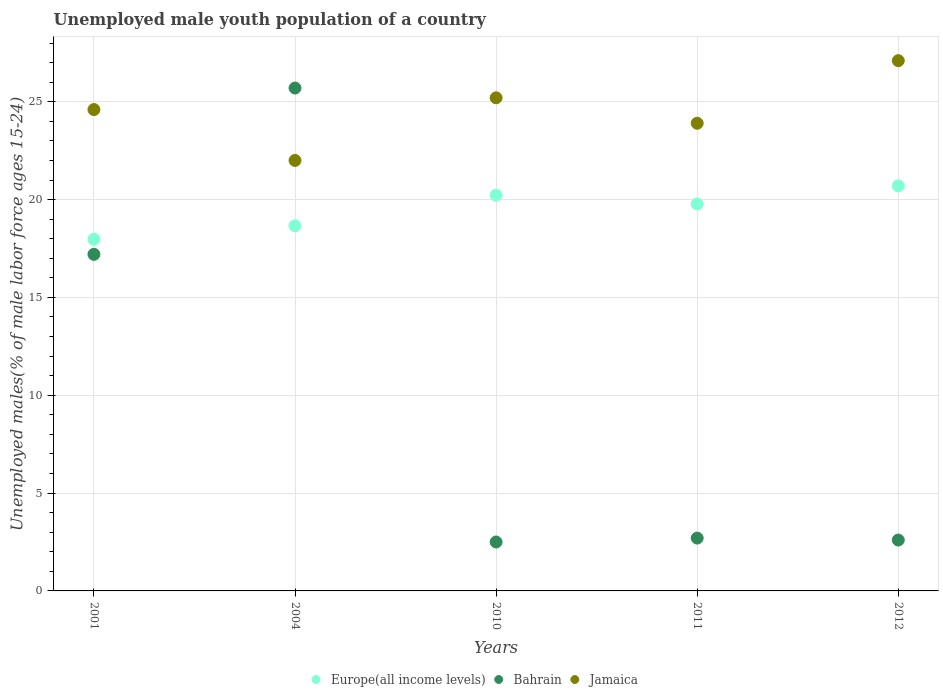How many different coloured dotlines are there?
Your response must be concise. 3. Is the number of dotlines equal to the number of legend labels?
Provide a succinct answer. Yes. What is the percentage of unemployed male youth population in Jamaica in 2004?
Your response must be concise. 22. Across all years, what is the maximum percentage of unemployed male youth population in Jamaica?
Provide a short and direct response. 27.1. In which year was the percentage of unemployed male youth population in Jamaica minimum?
Give a very brief answer. 2004. What is the total percentage of unemployed male youth population in Bahrain in the graph?
Give a very brief answer. 50.7. What is the difference between the percentage of unemployed male youth population in Europe(all income levels) in 2001 and that in 2011?
Your answer should be compact. -1.8. What is the difference between the percentage of unemployed male youth population in Europe(all income levels) in 2001 and the percentage of unemployed male youth population in Bahrain in 2010?
Give a very brief answer. 15.47. What is the average percentage of unemployed male youth population in Bahrain per year?
Your response must be concise. 10.14. In the year 2011, what is the difference between the percentage of unemployed male youth population in Jamaica and percentage of unemployed male youth population in Bahrain?
Your response must be concise. 21.2. In how many years, is the percentage of unemployed male youth population in Jamaica greater than 15 %?
Your answer should be very brief. 5. What is the ratio of the percentage of unemployed male youth population in Europe(all income levels) in 2001 to that in 2004?
Ensure brevity in your answer.  0.96. What is the difference between the highest and the second highest percentage of unemployed male youth population in Europe(all income levels)?
Your answer should be very brief. 0.48. What is the difference between the highest and the lowest percentage of unemployed male youth population in Bahrain?
Offer a very short reply. 23.2. Is the sum of the percentage of unemployed male youth population in Europe(all income levels) in 2010 and 2012 greater than the maximum percentage of unemployed male youth population in Jamaica across all years?
Offer a terse response. Yes. Is it the case that in every year, the sum of the percentage of unemployed male youth population in Jamaica and percentage of unemployed male youth population in Europe(all income levels)  is greater than the percentage of unemployed male youth population in Bahrain?
Your answer should be very brief. Yes. Does the percentage of unemployed male youth population in Europe(all income levels) monotonically increase over the years?
Make the answer very short. No. Is the percentage of unemployed male youth population in Jamaica strictly greater than the percentage of unemployed male youth population in Bahrain over the years?
Provide a short and direct response. No. How many dotlines are there?
Your answer should be compact. 3. What is the difference between two consecutive major ticks on the Y-axis?
Give a very brief answer. 5. Are the values on the major ticks of Y-axis written in scientific E-notation?
Provide a short and direct response. No. Does the graph contain any zero values?
Your response must be concise. No. How many legend labels are there?
Offer a very short reply. 3. What is the title of the graph?
Offer a very short reply. Unemployed male youth population of a country. What is the label or title of the X-axis?
Provide a succinct answer. Years. What is the label or title of the Y-axis?
Ensure brevity in your answer.  Unemployed males(% of male labor force ages 15-24). What is the Unemployed males(% of male labor force ages 15-24) of Europe(all income levels) in 2001?
Provide a succinct answer. 17.97. What is the Unemployed males(% of male labor force ages 15-24) in Bahrain in 2001?
Make the answer very short. 17.2. What is the Unemployed males(% of male labor force ages 15-24) of Jamaica in 2001?
Your answer should be very brief. 24.6. What is the Unemployed males(% of male labor force ages 15-24) in Europe(all income levels) in 2004?
Your response must be concise. 18.66. What is the Unemployed males(% of male labor force ages 15-24) of Bahrain in 2004?
Provide a succinct answer. 25.7. What is the Unemployed males(% of male labor force ages 15-24) of Europe(all income levels) in 2010?
Provide a short and direct response. 20.22. What is the Unemployed males(% of male labor force ages 15-24) of Jamaica in 2010?
Your answer should be compact. 25.2. What is the Unemployed males(% of male labor force ages 15-24) in Europe(all income levels) in 2011?
Keep it short and to the point. 19.77. What is the Unemployed males(% of male labor force ages 15-24) of Bahrain in 2011?
Offer a very short reply. 2.7. What is the Unemployed males(% of male labor force ages 15-24) in Jamaica in 2011?
Make the answer very short. 23.9. What is the Unemployed males(% of male labor force ages 15-24) in Europe(all income levels) in 2012?
Provide a short and direct response. 20.7. What is the Unemployed males(% of male labor force ages 15-24) of Bahrain in 2012?
Provide a short and direct response. 2.6. What is the Unemployed males(% of male labor force ages 15-24) in Jamaica in 2012?
Offer a very short reply. 27.1. Across all years, what is the maximum Unemployed males(% of male labor force ages 15-24) of Europe(all income levels)?
Keep it short and to the point. 20.7. Across all years, what is the maximum Unemployed males(% of male labor force ages 15-24) of Bahrain?
Your answer should be very brief. 25.7. Across all years, what is the maximum Unemployed males(% of male labor force ages 15-24) in Jamaica?
Make the answer very short. 27.1. Across all years, what is the minimum Unemployed males(% of male labor force ages 15-24) of Europe(all income levels)?
Offer a very short reply. 17.97. What is the total Unemployed males(% of male labor force ages 15-24) in Europe(all income levels) in the graph?
Provide a short and direct response. 97.33. What is the total Unemployed males(% of male labor force ages 15-24) in Bahrain in the graph?
Your response must be concise. 50.7. What is the total Unemployed males(% of male labor force ages 15-24) in Jamaica in the graph?
Provide a short and direct response. 122.8. What is the difference between the Unemployed males(% of male labor force ages 15-24) in Europe(all income levels) in 2001 and that in 2004?
Your response must be concise. -0.69. What is the difference between the Unemployed males(% of male labor force ages 15-24) of Jamaica in 2001 and that in 2004?
Give a very brief answer. 2.6. What is the difference between the Unemployed males(% of male labor force ages 15-24) in Europe(all income levels) in 2001 and that in 2010?
Give a very brief answer. -2.25. What is the difference between the Unemployed males(% of male labor force ages 15-24) in Jamaica in 2001 and that in 2010?
Keep it short and to the point. -0.6. What is the difference between the Unemployed males(% of male labor force ages 15-24) of Europe(all income levels) in 2001 and that in 2011?
Make the answer very short. -1.8. What is the difference between the Unemployed males(% of male labor force ages 15-24) of Bahrain in 2001 and that in 2011?
Your answer should be compact. 14.5. What is the difference between the Unemployed males(% of male labor force ages 15-24) of Jamaica in 2001 and that in 2011?
Offer a terse response. 0.7. What is the difference between the Unemployed males(% of male labor force ages 15-24) in Europe(all income levels) in 2001 and that in 2012?
Offer a very short reply. -2.73. What is the difference between the Unemployed males(% of male labor force ages 15-24) of Jamaica in 2001 and that in 2012?
Ensure brevity in your answer.  -2.5. What is the difference between the Unemployed males(% of male labor force ages 15-24) in Europe(all income levels) in 2004 and that in 2010?
Make the answer very short. -1.56. What is the difference between the Unemployed males(% of male labor force ages 15-24) of Bahrain in 2004 and that in 2010?
Keep it short and to the point. 23.2. What is the difference between the Unemployed males(% of male labor force ages 15-24) of Europe(all income levels) in 2004 and that in 2011?
Your answer should be very brief. -1.11. What is the difference between the Unemployed males(% of male labor force ages 15-24) of Europe(all income levels) in 2004 and that in 2012?
Make the answer very short. -2.04. What is the difference between the Unemployed males(% of male labor force ages 15-24) of Bahrain in 2004 and that in 2012?
Give a very brief answer. 23.1. What is the difference between the Unemployed males(% of male labor force ages 15-24) in Jamaica in 2004 and that in 2012?
Your response must be concise. -5.1. What is the difference between the Unemployed males(% of male labor force ages 15-24) in Europe(all income levels) in 2010 and that in 2011?
Make the answer very short. 0.45. What is the difference between the Unemployed males(% of male labor force ages 15-24) of Europe(all income levels) in 2010 and that in 2012?
Ensure brevity in your answer.  -0.48. What is the difference between the Unemployed males(% of male labor force ages 15-24) of Jamaica in 2010 and that in 2012?
Offer a terse response. -1.9. What is the difference between the Unemployed males(% of male labor force ages 15-24) in Europe(all income levels) in 2011 and that in 2012?
Give a very brief answer. -0.93. What is the difference between the Unemployed males(% of male labor force ages 15-24) of Europe(all income levels) in 2001 and the Unemployed males(% of male labor force ages 15-24) of Bahrain in 2004?
Offer a terse response. -7.73. What is the difference between the Unemployed males(% of male labor force ages 15-24) in Europe(all income levels) in 2001 and the Unemployed males(% of male labor force ages 15-24) in Jamaica in 2004?
Keep it short and to the point. -4.03. What is the difference between the Unemployed males(% of male labor force ages 15-24) in Bahrain in 2001 and the Unemployed males(% of male labor force ages 15-24) in Jamaica in 2004?
Your response must be concise. -4.8. What is the difference between the Unemployed males(% of male labor force ages 15-24) in Europe(all income levels) in 2001 and the Unemployed males(% of male labor force ages 15-24) in Bahrain in 2010?
Offer a very short reply. 15.47. What is the difference between the Unemployed males(% of male labor force ages 15-24) in Europe(all income levels) in 2001 and the Unemployed males(% of male labor force ages 15-24) in Jamaica in 2010?
Offer a terse response. -7.23. What is the difference between the Unemployed males(% of male labor force ages 15-24) in Bahrain in 2001 and the Unemployed males(% of male labor force ages 15-24) in Jamaica in 2010?
Offer a terse response. -8. What is the difference between the Unemployed males(% of male labor force ages 15-24) in Europe(all income levels) in 2001 and the Unemployed males(% of male labor force ages 15-24) in Bahrain in 2011?
Offer a terse response. 15.27. What is the difference between the Unemployed males(% of male labor force ages 15-24) of Europe(all income levels) in 2001 and the Unemployed males(% of male labor force ages 15-24) of Jamaica in 2011?
Provide a succinct answer. -5.93. What is the difference between the Unemployed males(% of male labor force ages 15-24) of Europe(all income levels) in 2001 and the Unemployed males(% of male labor force ages 15-24) of Bahrain in 2012?
Offer a terse response. 15.37. What is the difference between the Unemployed males(% of male labor force ages 15-24) in Europe(all income levels) in 2001 and the Unemployed males(% of male labor force ages 15-24) in Jamaica in 2012?
Keep it short and to the point. -9.13. What is the difference between the Unemployed males(% of male labor force ages 15-24) of Bahrain in 2001 and the Unemployed males(% of male labor force ages 15-24) of Jamaica in 2012?
Keep it short and to the point. -9.9. What is the difference between the Unemployed males(% of male labor force ages 15-24) of Europe(all income levels) in 2004 and the Unemployed males(% of male labor force ages 15-24) of Bahrain in 2010?
Offer a terse response. 16.16. What is the difference between the Unemployed males(% of male labor force ages 15-24) of Europe(all income levels) in 2004 and the Unemployed males(% of male labor force ages 15-24) of Jamaica in 2010?
Keep it short and to the point. -6.54. What is the difference between the Unemployed males(% of male labor force ages 15-24) in Europe(all income levels) in 2004 and the Unemployed males(% of male labor force ages 15-24) in Bahrain in 2011?
Make the answer very short. 15.96. What is the difference between the Unemployed males(% of male labor force ages 15-24) in Europe(all income levels) in 2004 and the Unemployed males(% of male labor force ages 15-24) in Jamaica in 2011?
Give a very brief answer. -5.24. What is the difference between the Unemployed males(% of male labor force ages 15-24) of Europe(all income levels) in 2004 and the Unemployed males(% of male labor force ages 15-24) of Bahrain in 2012?
Offer a very short reply. 16.06. What is the difference between the Unemployed males(% of male labor force ages 15-24) of Europe(all income levels) in 2004 and the Unemployed males(% of male labor force ages 15-24) of Jamaica in 2012?
Make the answer very short. -8.44. What is the difference between the Unemployed males(% of male labor force ages 15-24) of Europe(all income levels) in 2010 and the Unemployed males(% of male labor force ages 15-24) of Bahrain in 2011?
Give a very brief answer. 17.52. What is the difference between the Unemployed males(% of male labor force ages 15-24) in Europe(all income levels) in 2010 and the Unemployed males(% of male labor force ages 15-24) in Jamaica in 2011?
Your answer should be compact. -3.68. What is the difference between the Unemployed males(% of male labor force ages 15-24) of Bahrain in 2010 and the Unemployed males(% of male labor force ages 15-24) of Jamaica in 2011?
Offer a terse response. -21.4. What is the difference between the Unemployed males(% of male labor force ages 15-24) in Europe(all income levels) in 2010 and the Unemployed males(% of male labor force ages 15-24) in Bahrain in 2012?
Make the answer very short. 17.62. What is the difference between the Unemployed males(% of male labor force ages 15-24) in Europe(all income levels) in 2010 and the Unemployed males(% of male labor force ages 15-24) in Jamaica in 2012?
Your answer should be compact. -6.88. What is the difference between the Unemployed males(% of male labor force ages 15-24) in Bahrain in 2010 and the Unemployed males(% of male labor force ages 15-24) in Jamaica in 2012?
Provide a succinct answer. -24.6. What is the difference between the Unemployed males(% of male labor force ages 15-24) of Europe(all income levels) in 2011 and the Unemployed males(% of male labor force ages 15-24) of Bahrain in 2012?
Keep it short and to the point. 17.17. What is the difference between the Unemployed males(% of male labor force ages 15-24) of Europe(all income levels) in 2011 and the Unemployed males(% of male labor force ages 15-24) of Jamaica in 2012?
Keep it short and to the point. -7.33. What is the difference between the Unemployed males(% of male labor force ages 15-24) in Bahrain in 2011 and the Unemployed males(% of male labor force ages 15-24) in Jamaica in 2012?
Keep it short and to the point. -24.4. What is the average Unemployed males(% of male labor force ages 15-24) of Europe(all income levels) per year?
Ensure brevity in your answer.  19.47. What is the average Unemployed males(% of male labor force ages 15-24) of Bahrain per year?
Provide a succinct answer. 10.14. What is the average Unemployed males(% of male labor force ages 15-24) in Jamaica per year?
Your answer should be compact. 24.56. In the year 2001, what is the difference between the Unemployed males(% of male labor force ages 15-24) in Europe(all income levels) and Unemployed males(% of male labor force ages 15-24) in Bahrain?
Your answer should be compact. 0.77. In the year 2001, what is the difference between the Unemployed males(% of male labor force ages 15-24) of Europe(all income levels) and Unemployed males(% of male labor force ages 15-24) of Jamaica?
Ensure brevity in your answer.  -6.63. In the year 2001, what is the difference between the Unemployed males(% of male labor force ages 15-24) of Bahrain and Unemployed males(% of male labor force ages 15-24) of Jamaica?
Keep it short and to the point. -7.4. In the year 2004, what is the difference between the Unemployed males(% of male labor force ages 15-24) of Europe(all income levels) and Unemployed males(% of male labor force ages 15-24) of Bahrain?
Provide a succinct answer. -7.04. In the year 2004, what is the difference between the Unemployed males(% of male labor force ages 15-24) in Europe(all income levels) and Unemployed males(% of male labor force ages 15-24) in Jamaica?
Ensure brevity in your answer.  -3.34. In the year 2010, what is the difference between the Unemployed males(% of male labor force ages 15-24) in Europe(all income levels) and Unemployed males(% of male labor force ages 15-24) in Bahrain?
Keep it short and to the point. 17.72. In the year 2010, what is the difference between the Unemployed males(% of male labor force ages 15-24) in Europe(all income levels) and Unemployed males(% of male labor force ages 15-24) in Jamaica?
Give a very brief answer. -4.98. In the year 2010, what is the difference between the Unemployed males(% of male labor force ages 15-24) in Bahrain and Unemployed males(% of male labor force ages 15-24) in Jamaica?
Give a very brief answer. -22.7. In the year 2011, what is the difference between the Unemployed males(% of male labor force ages 15-24) of Europe(all income levels) and Unemployed males(% of male labor force ages 15-24) of Bahrain?
Offer a very short reply. 17.07. In the year 2011, what is the difference between the Unemployed males(% of male labor force ages 15-24) in Europe(all income levels) and Unemployed males(% of male labor force ages 15-24) in Jamaica?
Your answer should be very brief. -4.13. In the year 2011, what is the difference between the Unemployed males(% of male labor force ages 15-24) in Bahrain and Unemployed males(% of male labor force ages 15-24) in Jamaica?
Make the answer very short. -21.2. In the year 2012, what is the difference between the Unemployed males(% of male labor force ages 15-24) of Europe(all income levels) and Unemployed males(% of male labor force ages 15-24) of Bahrain?
Offer a very short reply. 18.1. In the year 2012, what is the difference between the Unemployed males(% of male labor force ages 15-24) in Europe(all income levels) and Unemployed males(% of male labor force ages 15-24) in Jamaica?
Offer a very short reply. -6.4. In the year 2012, what is the difference between the Unemployed males(% of male labor force ages 15-24) in Bahrain and Unemployed males(% of male labor force ages 15-24) in Jamaica?
Your answer should be compact. -24.5. What is the ratio of the Unemployed males(% of male labor force ages 15-24) of Bahrain in 2001 to that in 2004?
Offer a very short reply. 0.67. What is the ratio of the Unemployed males(% of male labor force ages 15-24) of Jamaica in 2001 to that in 2004?
Give a very brief answer. 1.12. What is the ratio of the Unemployed males(% of male labor force ages 15-24) of Europe(all income levels) in 2001 to that in 2010?
Make the answer very short. 0.89. What is the ratio of the Unemployed males(% of male labor force ages 15-24) in Bahrain in 2001 to that in 2010?
Provide a succinct answer. 6.88. What is the ratio of the Unemployed males(% of male labor force ages 15-24) of Jamaica in 2001 to that in 2010?
Offer a very short reply. 0.98. What is the ratio of the Unemployed males(% of male labor force ages 15-24) in Europe(all income levels) in 2001 to that in 2011?
Offer a very short reply. 0.91. What is the ratio of the Unemployed males(% of male labor force ages 15-24) of Bahrain in 2001 to that in 2011?
Your response must be concise. 6.37. What is the ratio of the Unemployed males(% of male labor force ages 15-24) in Jamaica in 2001 to that in 2011?
Keep it short and to the point. 1.03. What is the ratio of the Unemployed males(% of male labor force ages 15-24) in Europe(all income levels) in 2001 to that in 2012?
Your answer should be very brief. 0.87. What is the ratio of the Unemployed males(% of male labor force ages 15-24) in Bahrain in 2001 to that in 2012?
Offer a terse response. 6.62. What is the ratio of the Unemployed males(% of male labor force ages 15-24) of Jamaica in 2001 to that in 2012?
Offer a terse response. 0.91. What is the ratio of the Unemployed males(% of male labor force ages 15-24) of Europe(all income levels) in 2004 to that in 2010?
Ensure brevity in your answer.  0.92. What is the ratio of the Unemployed males(% of male labor force ages 15-24) in Bahrain in 2004 to that in 2010?
Keep it short and to the point. 10.28. What is the ratio of the Unemployed males(% of male labor force ages 15-24) of Jamaica in 2004 to that in 2010?
Ensure brevity in your answer.  0.87. What is the ratio of the Unemployed males(% of male labor force ages 15-24) in Europe(all income levels) in 2004 to that in 2011?
Make the answer very short. 0.94. What is the ratio of the Unemployed males(% of male labor force ages 15-24) of Bahrain in 2004 to that in 2011?
Provide a short and direct response. 9.52. What is the ratio of the Unemployed males(% of male labor force ages 15-24) in Jamaica in 2004 to that in 2011?
Make the answer very short. 0.92. What is the ratio of the Unemployed males(% of male labor force ages 15-24) of Europe(all income levels) in 2004 to that in 2012?
Offer a very short reply. 0.9. What is the ratio of the Unemployed males(% of male labor force ages 15-24) in Bahrain in 2004 to that in 2012?
Your response must be concise. 9.88. What is the ratio of the Unemployed males(% of male labor force ages 15-24) of Jamaica in 2004 to that in 2012?
Your answer should be very brief. 0.81. What is the ratio of the Unemployed males(% of male labor force ages 15-24) in Europe(all income levels) in 2010 to that in 2011?
Your response must be concise. 1.02. What is the ratio of the Unemployed males(% of male labor force ages 15-24) of Bahrain in 2010 to that in 2011?
Your answer should be compact. 0.93. What is the ratio of the Unemployed males(% of male labor force ages 15-24) of Jamaica in 2010 to that in 2011?
Your answer should be compact. 1.05. What is the ratio of the Unemployed males(% of male labor force ages 15-24) in Europe(all income levels) in 2010 to that in 2012?
Keep it short and to the point. 0.98. What is the ratio of the Unemployed males(% of male labor force ages 15-24) of Bahrain in 2010 to that in 2012?
Offer a very short reply. 0.96. What is the ratio of the Unemployed males(% of male labor force ages 15-24) of Jamaica in 2010 to that in 2012?
Keep it short and to the point. 0.93. What is the ratio of the Unemployed males(% of male labor force ages 15-24) of Europe(all income levels) in 2011 to that in 2012?
Your answer should be very brief. 0.96. What is the ratio of the Unemployed males(% of male labor force ages 15-24) of Jamaica in 2011 to that in 2012?
Ensure brevity in your answer.  0.88. What is the difference between the highest and the second highest Unemployed males(% of male labor force ages 15-24) in Europe(all income levels)?
Make the answer very short. 0.48. What is the difference between the highest and the second highest Unemployed males(% of male labor force ages 15-24) of Bahrain?
Provide a succinct answer. 8.5. What is the difference between the highest and the second highest Unemployed males(% of male labor force ages 15-24) of Jamaica?
Make the answer very short. 1.9. What is the difference between the highest and the lowest Unemployed males(% of male labor force ages 15-24) in Europe(all income levels)?
Keep it short and to the point. 2.73. What is the difference between the highest and the lowest Unemployed males(% of male labor force ages 15-24) of Bahrain?
Offer a terse response. 23.2. What is the difference between the highest and the lowest Unemployed males(% of male labor force ages 15-24) in Jamaica?
Your answer should be compact. 5.1. 